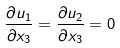<formula> <loc_0><loc_0><loc_500><loc_500>\frac { \partial u _ { 1 } } { \partial x _ { 3 } } = \frac { \partial u _ { 2 } } { \partial x _ { 3 } } = 0</formula> 